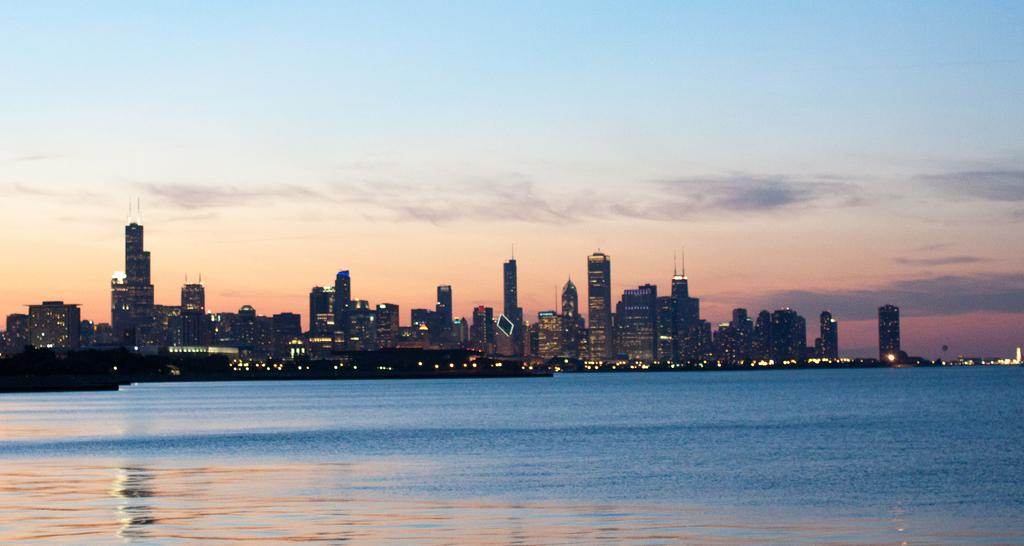What can be seen in the image that provides illumination? There are lights in the image. What type of structures are present in the image? There are buildings in the image. What natural element is visible in the image? Water is visible in the image. What is visible in the background of the image? The sky is visible in the background of the image. What can be seen in the sky? There are clouds in the sky. Where are the cats located in the image? There are no cats present in the image. What type of goods can be found at the market in the image? There is no market present in the image. 